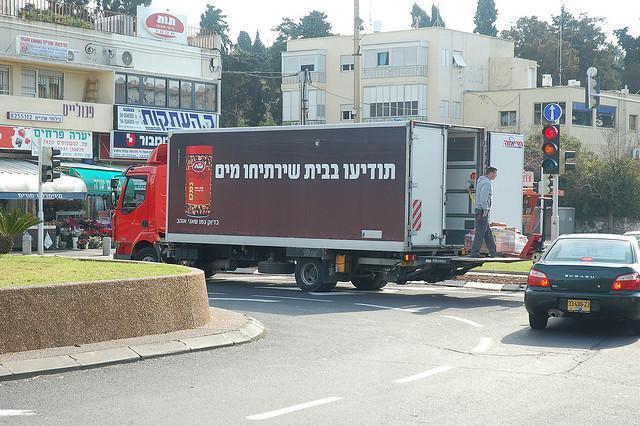How many vehicles are in the scene?
Give a very brief answer. 2. How many trucks are parked on the road?
Give a very brief answer. 1. 